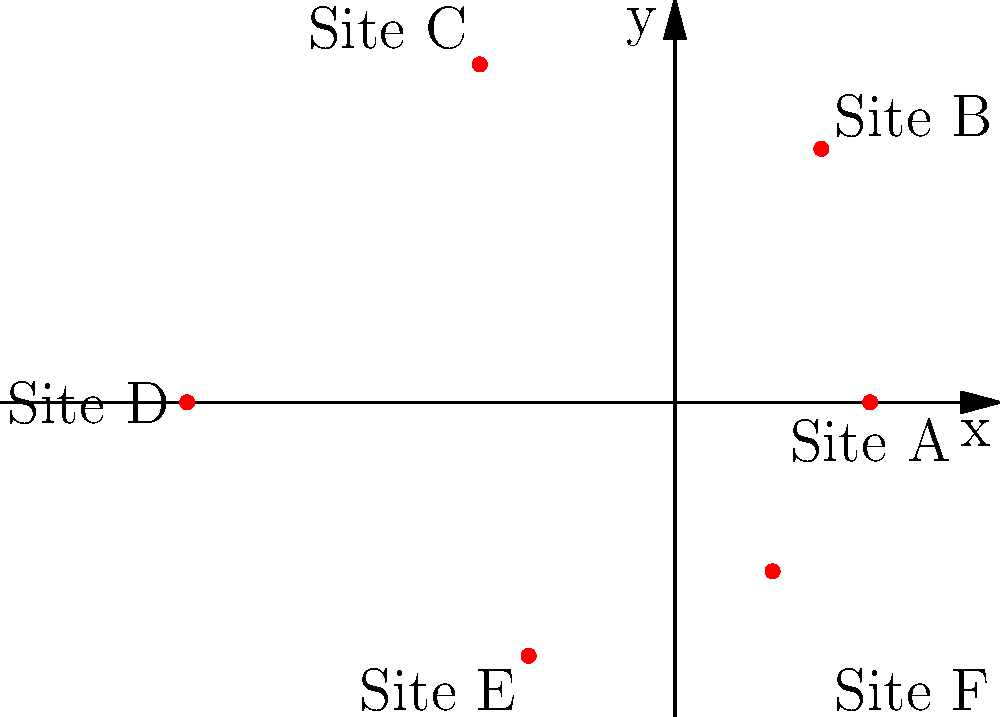In the polar coordinate plot representing the distribution of ancient wall paintings across different archaeological sites, which site has the highest concentration of paintings, and what is its corresponding polar coordinate $(r,\theta)$? To answer this question, we need to follow these steps:

1. Understand that in polar coordinates, the distance from the origin $(r)$ represents the concentration of paintings, while the angle $(\theta)$ represents the location of the site.

2. Identify the points on the plot:
   Site A: $(2, 0)$
   Site B: $(3, \pi/3)$
   Site C: $(4, 2\pi/3)$
   Site D: $(5, \pi)$
   Site E: $(3, 4\pi/3)$
   Site F: $(2, 5\pi/3)$

3. Compare the $r$ values, as they represent the concentration of paintings:
   Site A: $r = 2$
   Site B: $r = 3$
   Site C: $r = 4$
   Site D: $r = 5$
   Site E: $r = 3$
   Site F: $r = 2$

4. The highest $r$ value is 5, corresponding to Site D.

5. The polar coordinate for Site D is $(5, \pi)$.

Therefore, Site D has the highest concentration of ancient wall paintings, with the polar coordinate $(5, \pi)$.
Answer: Site D, $(5, \pi)$ 